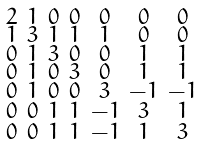Convert formula to latex. <formula><loc_0><loc_0><loc_500><loc_500>\begin{smallmatrix} 2 & 1 & 0 & 0 & 0 & 0 & 0 \\ 1 & 3 & 1 & 1 & 1 & 0 & 0 \\ 0 & 1 & 3 & 0 & 0 & 1 & 1 \\ 0 & 1 & 0 & 3 & 0 & 1 & 1 \\ 0 & 1 & 0 & 0 & 3 & - 1 & - 1 \\ 0 & 0 & 1 & 1 & - 1 & 3 & 1 \\ 0 & 0 & 1 & 1 & - 1 & 1 & 3 \end{smallmatrix}</formula> 